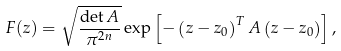Convert formula to latex. <formula><loc_0><loc_0><loc_500><loc_500>F ( z ) = \sqrt { \frac { \det A } { \pi ^ { 2 n } } } \exp \left [ - \left ( z - z _ { 0 } \right ) ^ { T } A \left ( z - z _ { 0 } \right ) \right ] ,</formula> 